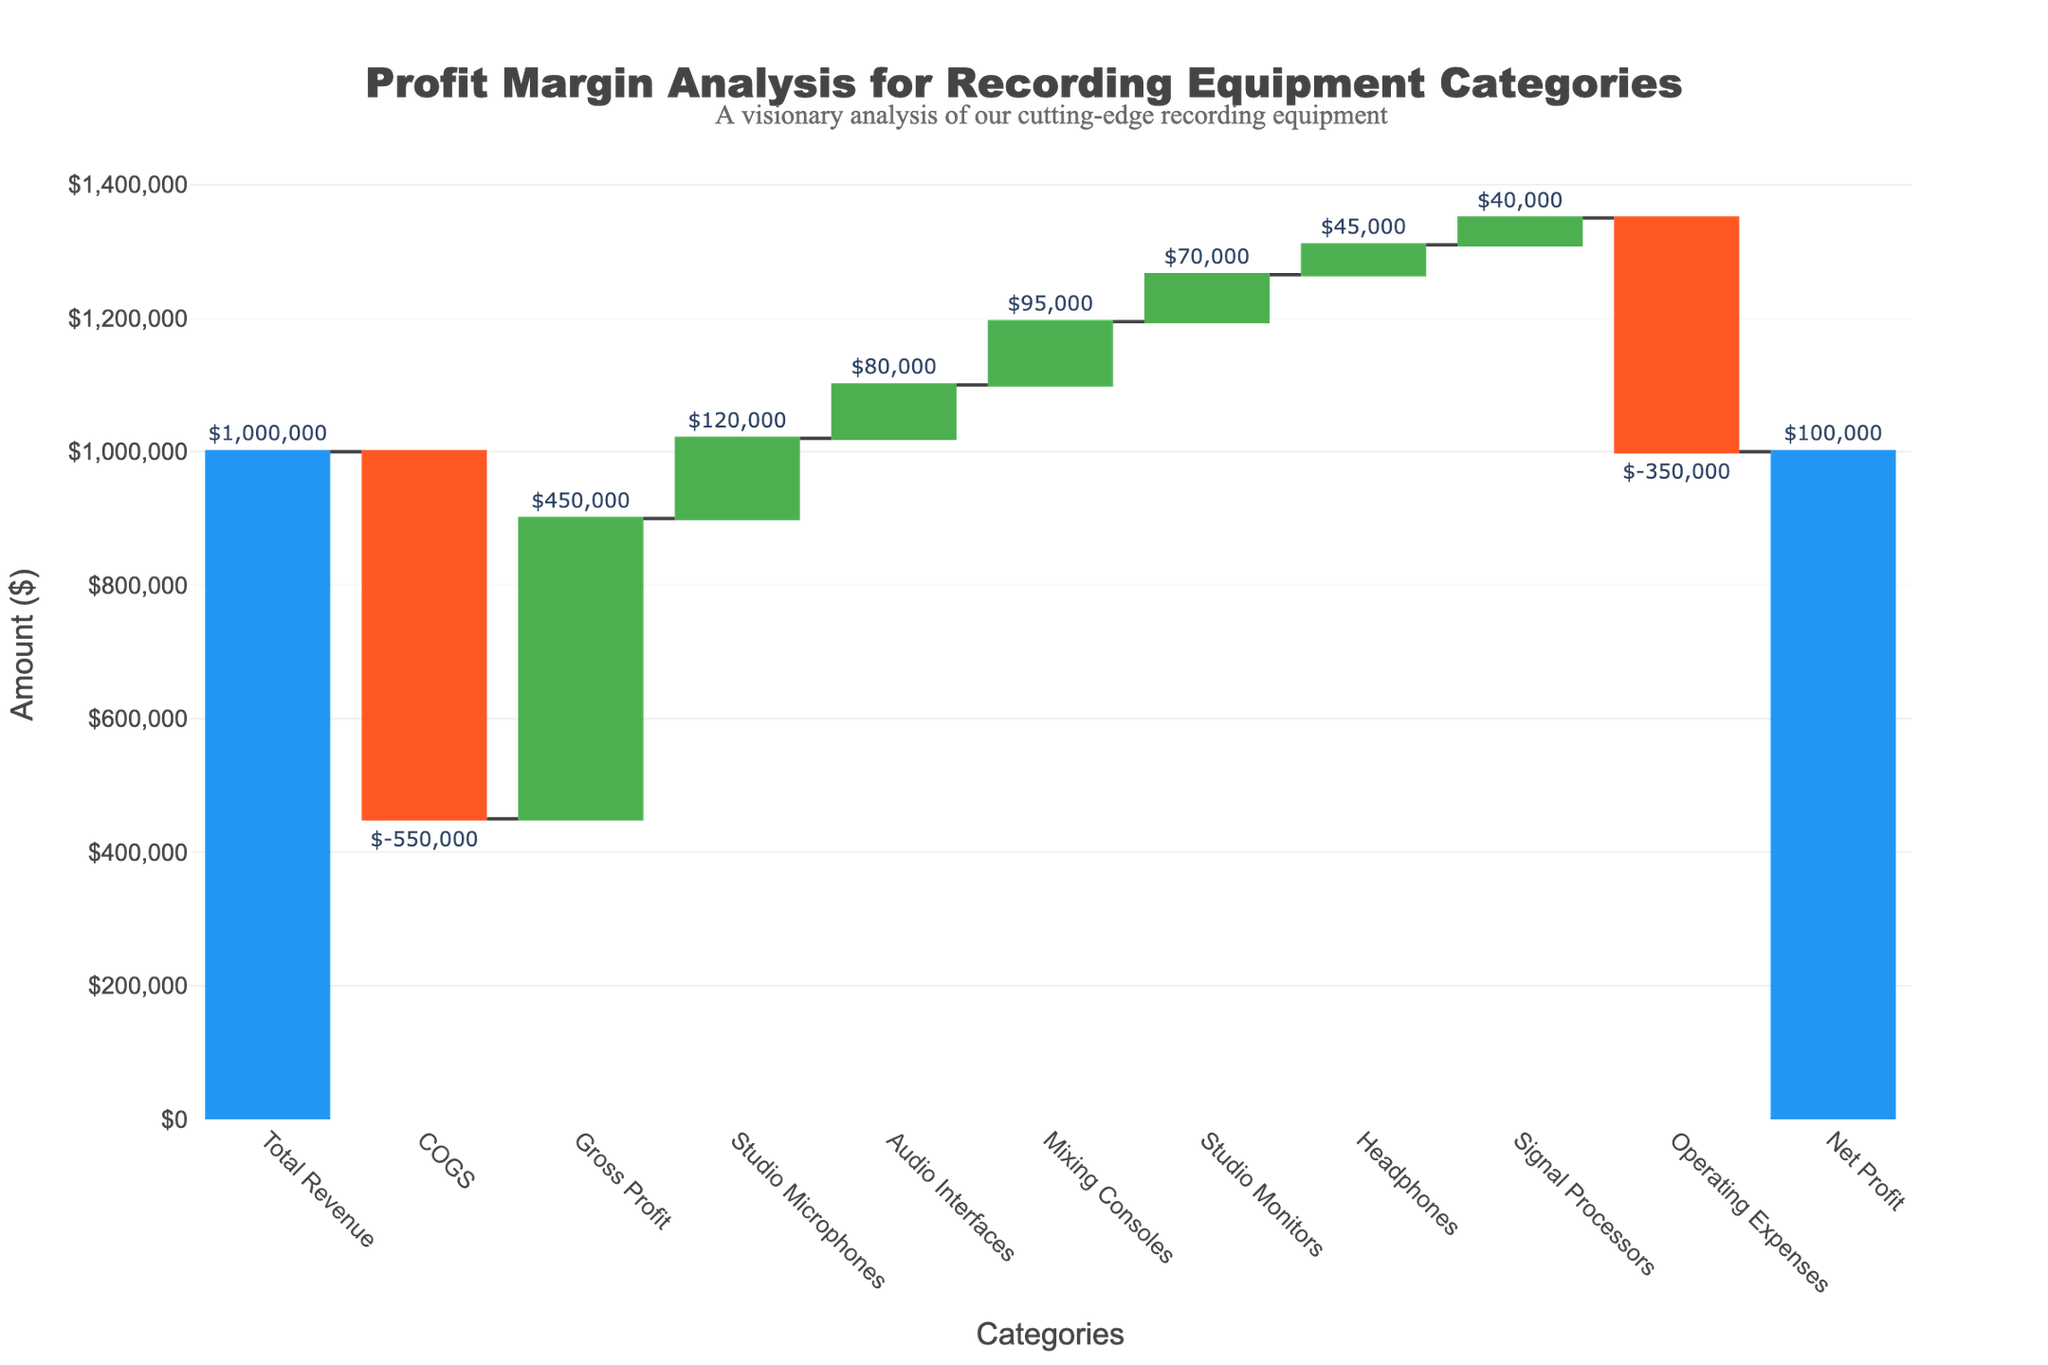What's the total revenue for the recording equipment categories? The total revenue is at the start of the chart, labeled as "Total Revenue". The value indicated is $1,000,000.
Answer: $1,000,000 What is the net profit? The net profit is at the end of the chart, labeled as "Net Profit". The value indicated is $100,000.
Answer: $100,000 How much do operating expenses contribute to the profit margin? The contribution of operating expenses is shown as a decrease labeled "Operating Expenses". The value is $350,000.
Answer: $350,000 Which category has the highest contribution to the gross profit? Compare all categories that contribute to gross profit. "Studio Microphones" has the highest value of $120,000.
Answer: Studio Microphones Which two categories have the smallest contributions to the profit margin? Examining the chart, "Signal Processors" and "Headphones" have the smallest increases with values of $40,000 and $45,000, respectively.
Answer: Signal Processors, Headphones How does the gross profit compare with the total revenue? Gross profit is derived after subtracting the cost of goods sold (COGS) from total revenue. Total revenue is $1,000,000, and gross profit is $450,000.
Answer: $550,000 difference What is the combined contribution of Studio Monitors and Mixing Consoles to the profit margin? Studio Monitors contribute $70,000 and Mixing Consoles contribute $95,000. Combined, they contribute $70,000 + $95,000 = $165,000.
Answer: $165,000 What category has the lowest increase in profit contribution? Within the increasing measures (ignoring costs), "Signal Processors" has the lowest value increase of $40,000.
Answer: Signal Processors If the operating expenses were reduced by 50%, what would be the new net profit? Current operating expenses are $350,000. Reducing it by 50% gives $175,000. The current net profit is $100,000. Adding the reduction in expenses ($350,000 - $175,000) results in a new net profit of $100,000 + $175,000.
Answer: $275,000 